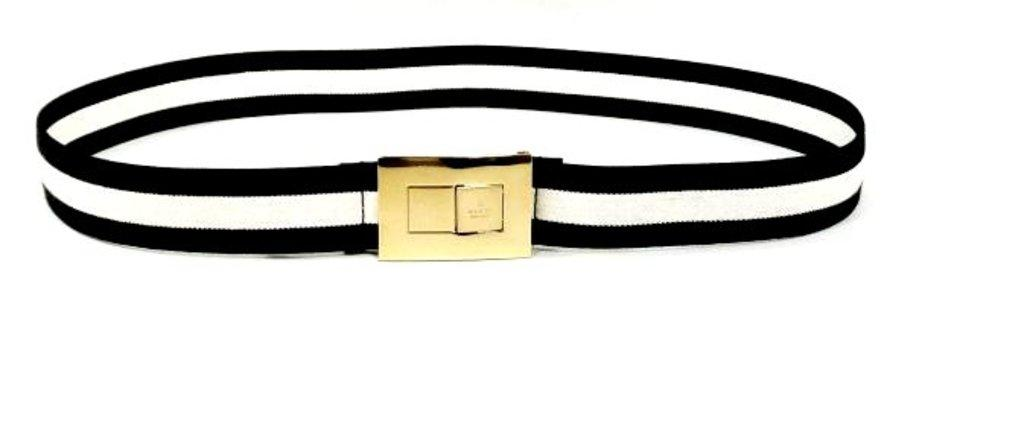What is the main object in the picture? There is a bracelet in the picture. What colors are used in the bracelet? The bracelet is in black and white color. Is there any other object near the bracelet? Yes, there is a golden color object in between the bracelet. How many ducks are present in the picture? There are no ducks present in the picture; it features a bracelet and a golden color object. What is the relationship between the bracelet and the person's mom in the picture? There is no person or mom mentioned in the picture; it only shows a bracelet and a golden color object. 